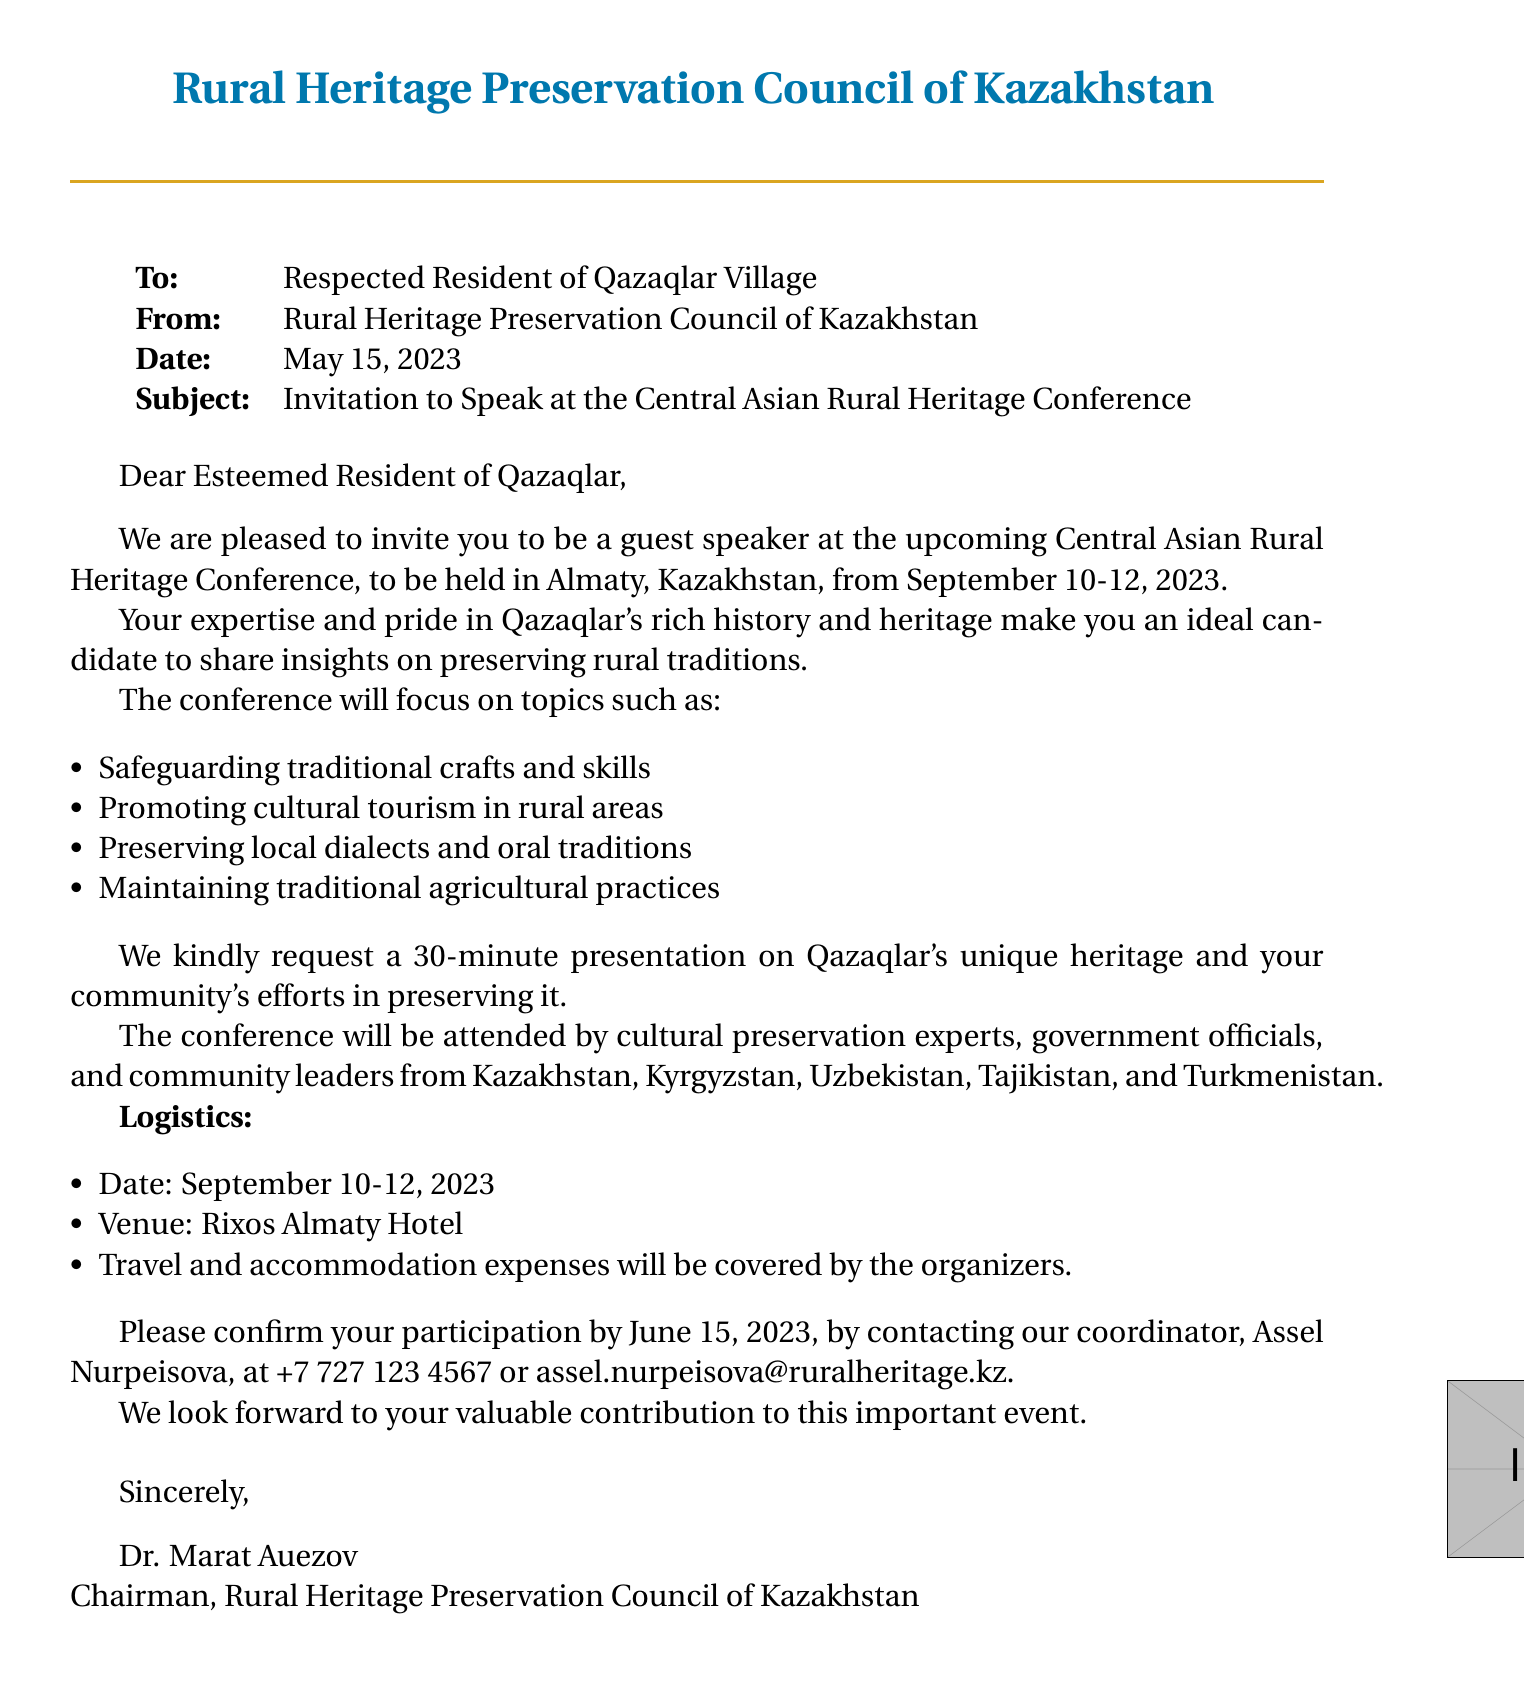What is the title of the event? The title of the event mentioned in the document is "Central Asian Rural Heritage Conference."
Answer: Central Asian Rural Heritage Conference Who is the sender of the fax? The document specifies that the sender is the "Rural Heritage Preservation Council of Kazakhstan."
Answer: Rural Heritage Preservation Council of Kazakhstan What are the dates of the conference? The conference is scheduled to take place from September 10 to September 12, 2023, according to the document.
Answer: September 10-12, 2023 What city will host the conference? The document indicates that the conference will be held in "Almaty, Kazakhstan."
Answer: Almaty What is the requested length of the presentation? The invitation states that a "30-minute" presentation is requested from the recipient.
Answer: 30-minute What will the organizers cover regarding travel? The document mentions that "travel and accommodation expenses will be covered by the organizers."
Answer: Travel and accommodation expenses Who is the contact person for confirming participation? The fax lists "Assel Nurpeisova" as the contact person for confirmation.
Answer: Assel Nurpeisova What is one of the conference focus topics? The document lists several topics; one example is "Safeguarding traditional crafts and skills."
Answer: Safeguarding traditional crafts and skills What is the venue for the conference? The venue specified in the document is the "Rixos Almaty Hotel."
Answer: Rixos Almaty Hotel 